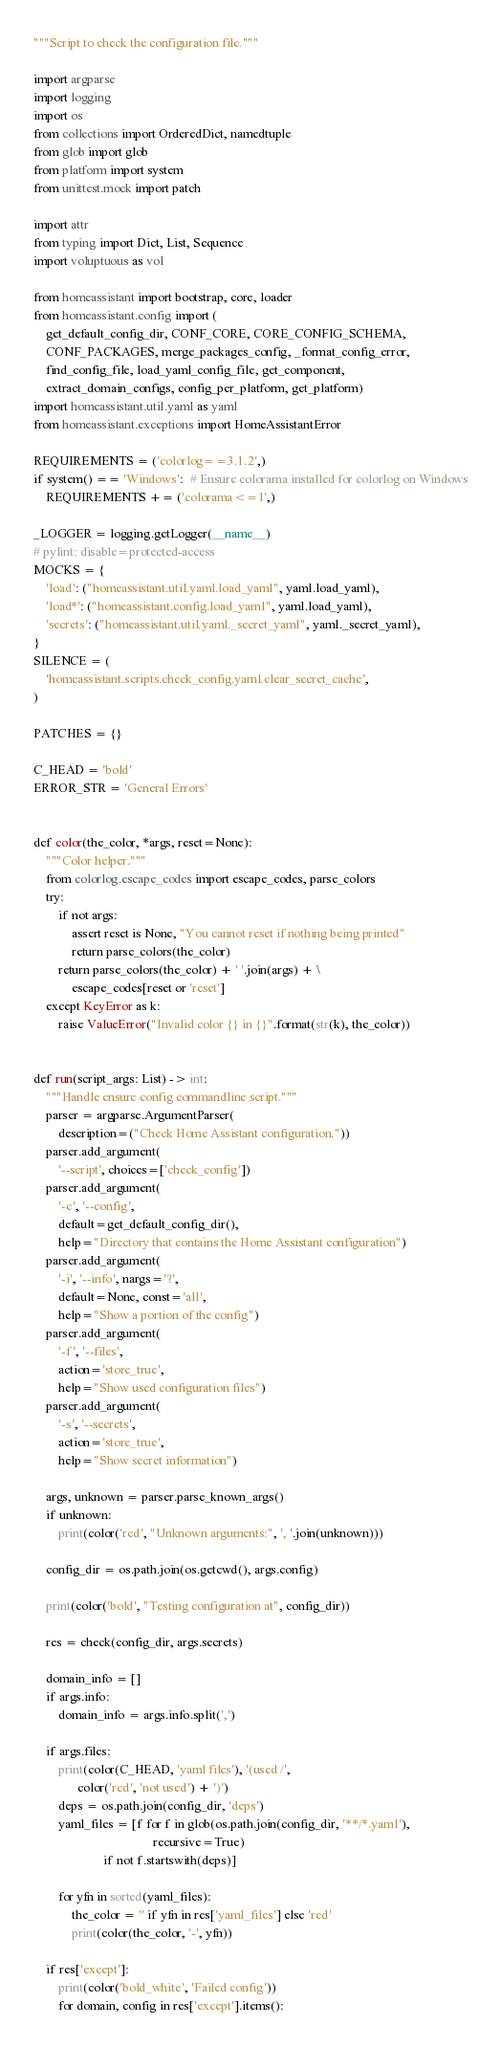<code> <loc_0><loc_0><loc_500><loc_500><_Python_>"""Script to check the configuration file."""

import argparse
import logging
import os
from collections import OrderedDict, namedtuple
from glob import glob
from platform import system
from unittest.mock import patch

import attr
from typing import Dict, List, Sequence
import voluptuous as vol

from homeassistant import bootstrap, core, loader
from homeassistant.config import (
    get_default_config_dir, CONF_CORE, CORE_CONFIG_SCHEMA,
    CONF_PACKAGES, merge_packages_config, _format_config_error,
    find_config_file, load_yaml_config_file, get_component,
    extract_domain_configs, config_per_platform, get_platform)
import homeassistant.util.yaml as yaml
from homeassistant.exceptions import HomeAssistantError

REQUIREMENTS = ('colorlog==3.1.2',)
if system() == 'Windows':  # Ensure colorama installed for colorlog on Windows
    REQUIREMENTS += ('colorama<=1',)

_LOGGER = logging.getLogger(__name__)
# pylint: disable=protected-access
MOCKS = {
    'load': ("homeassistant.util.yaml.load_yaml", yaml.load_yaml),
    'load*': ("homeassistant.config.load_yaml", yaml.load_yaml),
    'secrets': ("homeassistant.util.yaml._secret_yaml", yaml._secret_yaml),
}
SILENCE = (
    'homeassistant.scripts.check_config.yaml.clear_secret_cache',
)

PATCHES = {}

C_HEAD = 'bold'
ERROR_STR = 'General Errors'


def color(the_color, *args, reset=None):
    """Color helper."""
    from colorlog.escape_codes import escape_codes, parse_colors
    try:
        if not args:
            assert reset is None, "You cannot reset if nothing being printed"
            return parse_colors(the_color)
        return parse_colors(the_color) + ' '.join(args) + \
            escape_codes[reset or 'reset']
    except KeyError as k:
        raise ValueError("Invalid color {} in {}".format(str(k), the_color))


def run(script_args: List) -> int:
    """Handle ensure config commandline script."""
    parser = argparse.ArgumentParser(
        description=("Check Home Assistant configuration."))
    parser.add_argument(
        '--script', choices=['check_config'])
    parser.add_argument(
        '-c', '--config',
        default=get_default_config_dir(),
        help="Directory that contains the Home Assistant configuration")
    parser.add_argument(
        '-i', '--info', nargs='?',
        default=None, const='all',
        help="Show a portion of the config")
    parser.add_argument(
        '-f', '--files',
        action='store_true',
        help="Show used configuration files")
    parser.add_argument(
        '-s', '--secrets',
        action='store_true',
        help="Show secret information")

    args, unknown = parser.parse_known_args()
    if unknown:
        print(color('red', "Unknown arguments:", ', '.join(unknown)))

    config_dir = os.path.join(os.getcwd(), args.config)

    print(color('bold', "Testing configuration at", config_dir))

    res = check(config_dir, args.secrets)

    domain_info = []
    if args.info:
        domain_info = args.info.split(',')

    if args.files:
        print(color(C_HEAD, 'yaml files'), '(used /',
              color('red', 'not used') + ')')
        deps = os.path.join(config_dir, 'deps')
        yaml_files = [f for f in glob(os.path.join(config_dir, '**/*.yaml'),
                                      recursive=True)
                      if not f.startswith(deps)]

        for yfn in sorted(yaml_files):
            the_color = '' if yfn in res['yaml_files'] else 'red'
            print(color(the_color, '-', yfn))

    if res['except']:
        print(color('bold_white', 'Failed config'))
        for domain, config in res['except'].items():</code> 